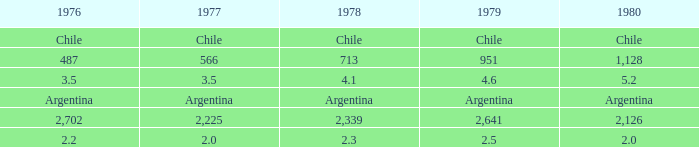What is the value of 1976 if 1980 equals 2.2. 